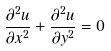Convert formula to latex. <formula><loc_0><loc_0><loc_500><loc_500>\frac { \partial ^ { 2 } u } { \partial x ^ { 2 } } + \frac { \partial ^ { 2 } u } { \partial y ^ { 2 } } = 0</formula> 